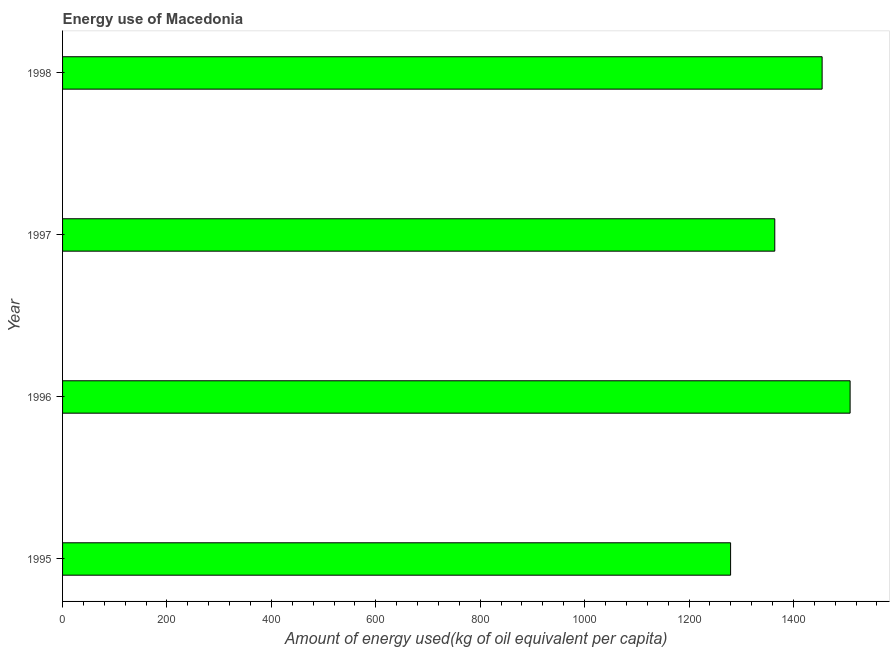Does the graph contain grids?
Ensure brevity in your answer.  No. What is the title of the graph?
Provide a short and direct response. Energy use of Macedonia. What is the label or title of the X-axis?
Your answer should be very brief. Amount of energy used(kg of oil equivalent per capita). What is the amount of energy used in 1996?
Offer a terse response. 1508.58. Across all years, what is the maximum amount of energy used?
Offer a very short reply. 1508.58. Across all years, what is the minimum amount of energy used?
Offer a very short reply. 1279.64. In which year was the amount of energy used maximum?
Offer a terse response. 1996. What is the sum of the amount of energy used?
Make the answer very short. 5607.43. What is the difference between the amount of energy used in 1997 and 1998?
Provide a short and direct response. -90.68. What is the average amount of energy used per year?
Provide a short and direct response. 1401.86. What is the median amount of energy used?
Your response must be concise. 1409.61. In how many years, is the amount of energy used greater than 1480 kg?
Ensure brevity in your answer.  1. What is the ratio of the amount of energy used in 1997 to that in 1998?
Your response must be concise. 0.94. Is the amount of energy used in 1996 less than that in 1997?
Ensure brevity in your answer.  No. Is the difference between the amount of energy used in 1996 and 1998 greater than the difference between any two years?
Ensure brevity in your answer.  No. What is the difference between the highest and the second highest amount of energy used?
Provide a short and direct response. 53.63. Is the sum of the amount of energy used in 1997 and 1998 greater than the maximum amount of energy used across all years?
Give a very brief answer. Yes. What is the difference between the highest and the lowest amount of energy used?
Provide a succinct answer. 228.93. How many years are there in the graph?
Make the answer very short. 4. What is the Amount of energy used(kg of oil equivalent per capita) in 1995?
Keep it short and to the point. 1279.64. What is the Amount of energy used(kg of oil equivalent per capita) of 1996?
Provide a succinct answer. 1508.58. What is the Amount of energy used(kg of oil equivalent per capita) in 1997?
Make the answer very short. 1364.27. What is the Amount of energy used(kg of oil equivalent per capita) of 1998?
Provide a succinct answer. 1454.95. What is the difference between the Amount of energy used(kg of oil equivalent per capita) in 1995 and 1996?
Offer a terse response. -228.93. What is the difference between the Amount of energy used(kg of oil equivalent per capita) in 1995 and 1997?
Offer a very short reply. -84.63. What is the difference between the Amount of energy used(kg of oil equivalent per capita) in 1995 and 1998?
Your answer should be very brief. -175.3. What is the difference between the Amount of energy used(kg of oil equivalent per capita) in 1996 and 1997?
Your answer should be very brief. 144.31. What is the difference between the Amount of energy used(kg of oil equivalent per capita) in 1996 and 1998?
Your answer should be very brief. 53.63. What is the difference between the Amount of energy used(kg of oil equivalent per capita) in 1997 and 1998?
Make the answer very short. -90.68. What is the ratio of the Amount of energy used(kg of oil equivalent per capita) in 1995 to that in 1996?
Provide a succinct answer. 0.85. What is the ratio of the Amount of energy used(kg of oil equivalent per capita) in 1995 to that in 1997?
Provide a short and direct response. 0.94. What is the ratio of the Amount of energy used(kg of oil equivalent per capita) in 1995 to that in 1998?
Your answer should be compact. 0.88. What is the ratio of the Amount of energy used(kg of oil equivalent per capita) in 1996 to that in 1997?
Ensure brevity in your answer.  1.11. What is the ratio of the Amount of energy used(kg of oil equivalent per capita) in 1997 to that in 1998?
Provide a short and direct response. 0.94. 